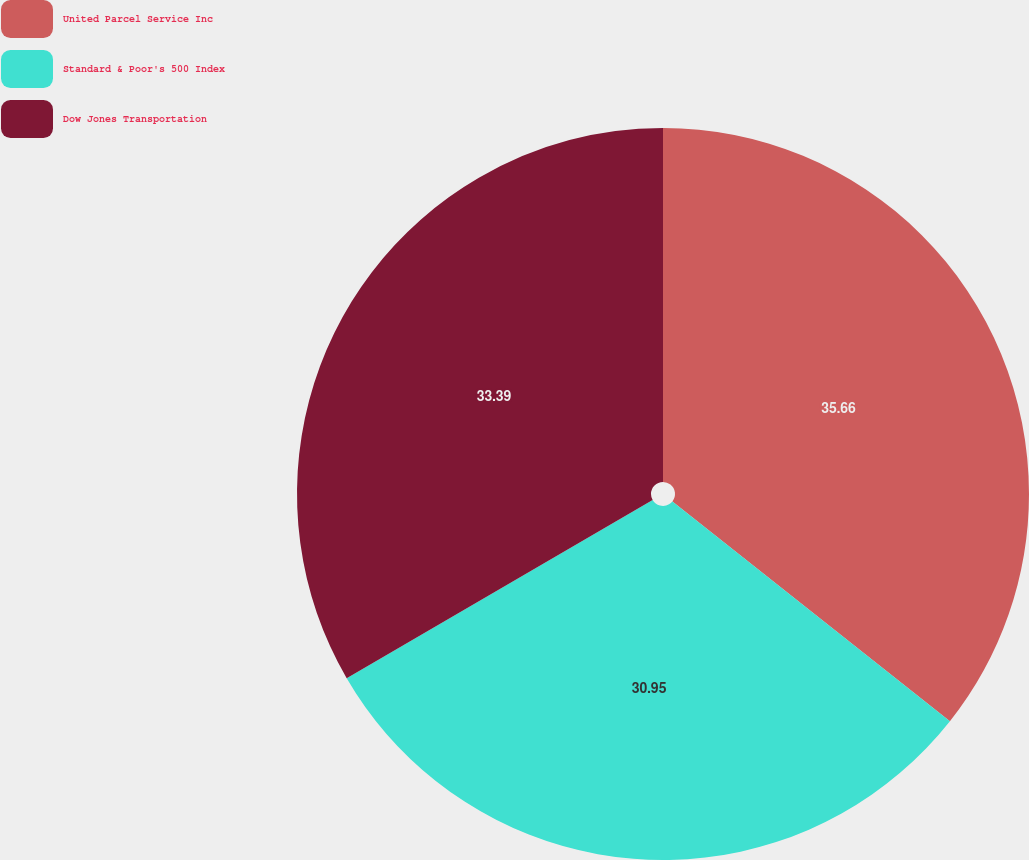Convert chart. <chart><loc_0><loc_0><loc_500><loc_500><pie_chart><fcel>United Parcel Service Inc<fcel>Standard & Poor's 500 Index<fcel>Dow Jones Transportation<nl><fcel>35.66%<fcel>30.95%<fcel>33.39%<nl></chart> 